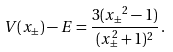Convert formula to latex. <formula><loc_0><loc_0><loc_500><loc_500>V ( x _ { \pm } ) - E = \frac { 3 ( { x _ { \pm } } ^ { 2 } - 1 ) } { ( x _ { \pm } ^ { 2 } + 1 ) ^ { 2 } } \, .</formula> 